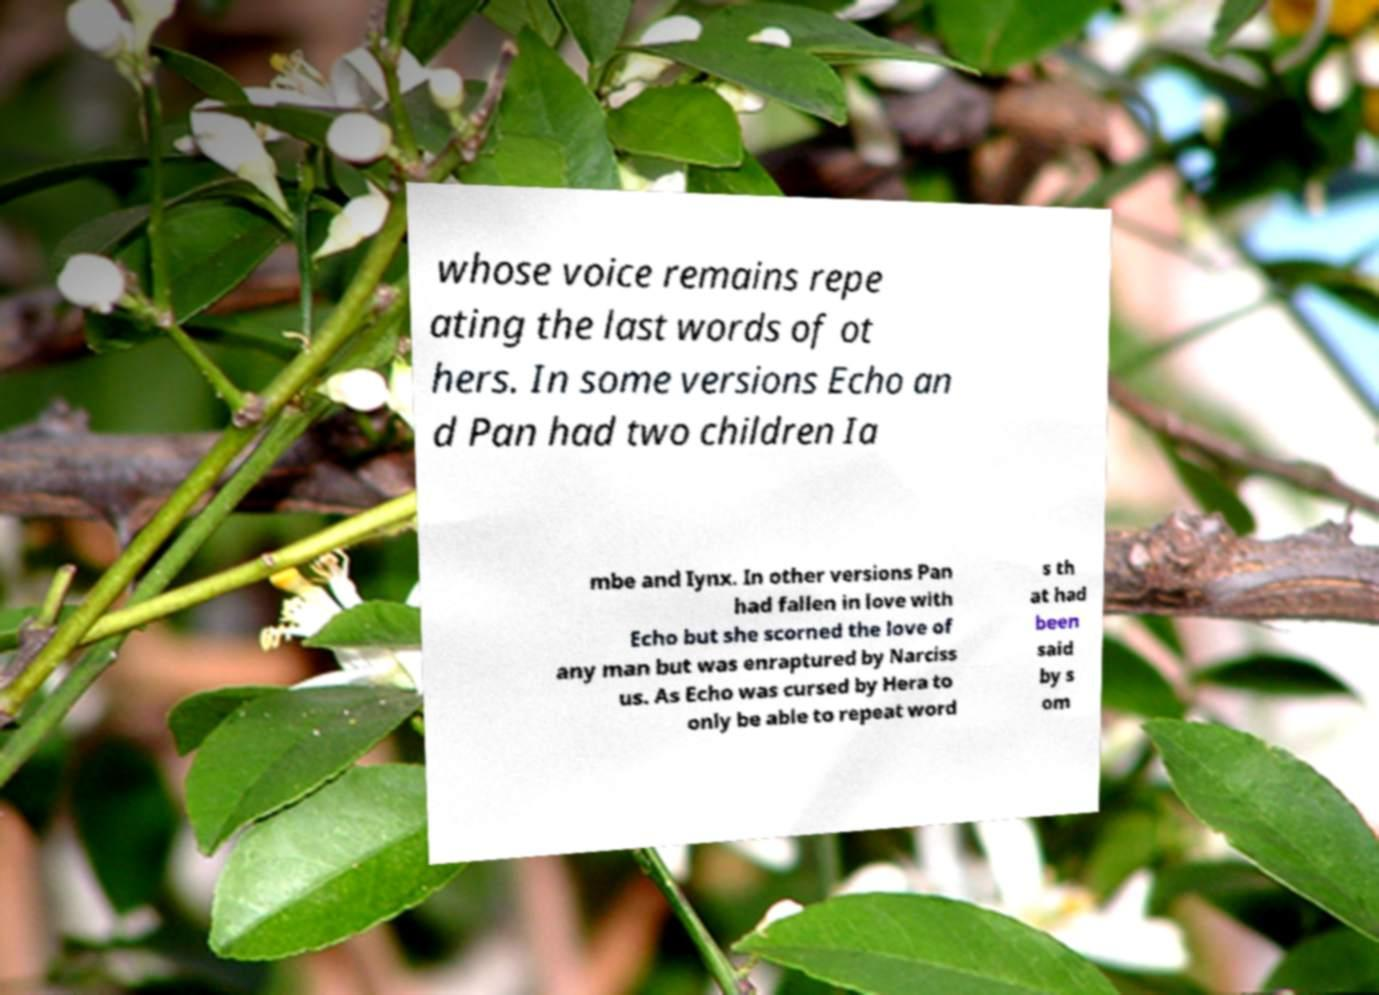Can you read and provide the text displayed in the image?This photo seems to have some interesting text. Can you extract and type it out for me? whose voice remains repe ating the last words of ot hers. In some versions Echo an d Pan had two children Ia mbe and Iynx. In other versions Pan had fallen in love with Echo but she scorned the love of any man but was enraptured by Narciss us. As Echo was cursed by Hera to only be able to repeat word s th at had been said by s om 